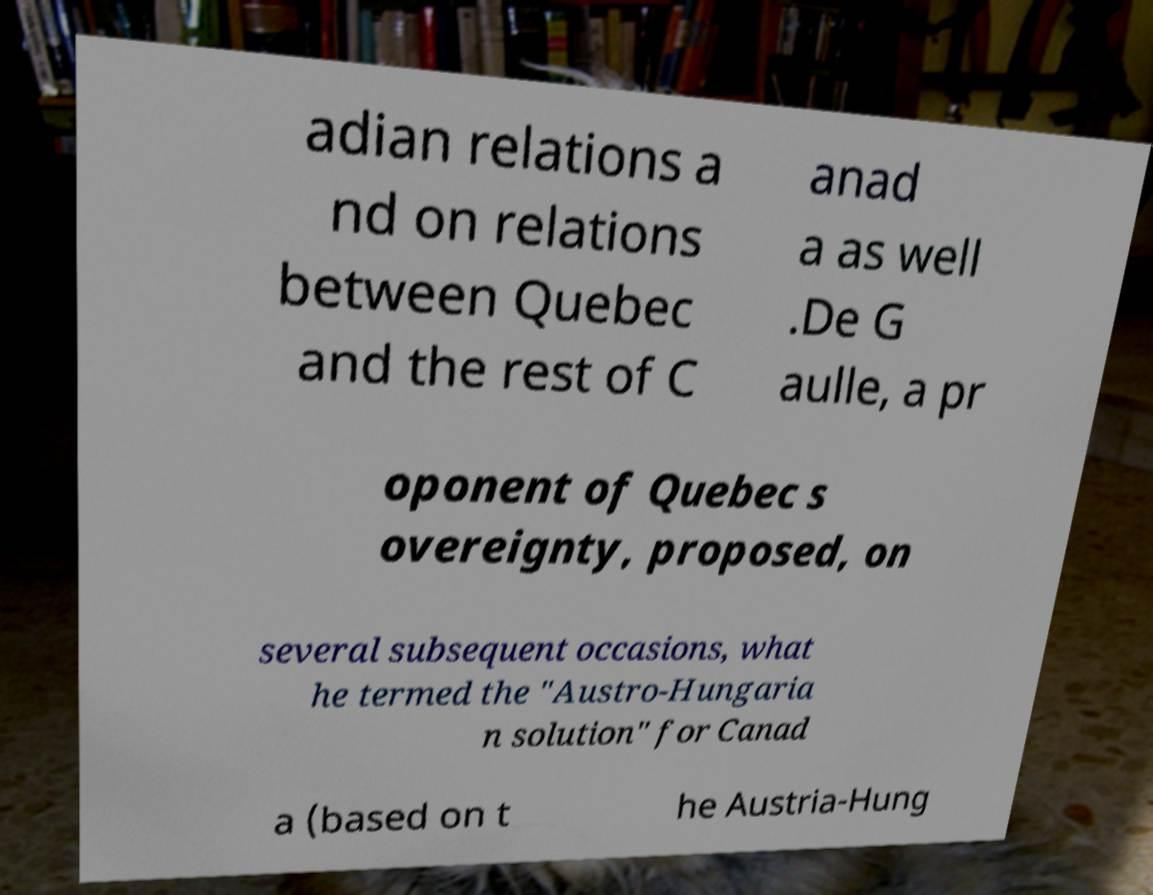What messages or text are displayed in this image? I need them in a readable, typed format. adian relations a nd on relations between Quebec and the rest of C anad a as well .De G aulle, a pr oponent of Quebec s overeignty, proposed, on several subsequent occasions, what he termed the "Austro-Hungaria n solution" for Canad a (based on t he Austria-Hung 